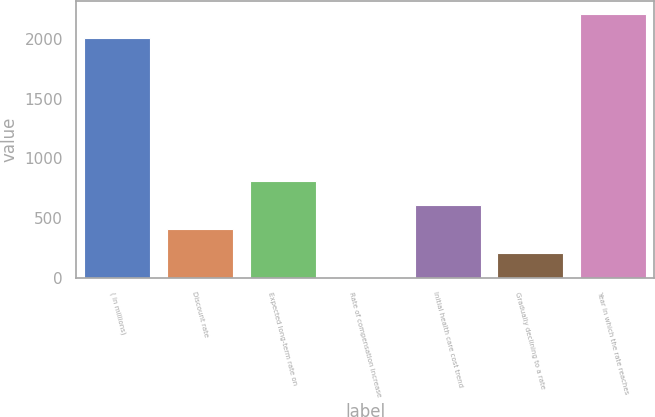<chart> <loc_0><loc_0><loc_500><loc_500><bar_chart><fcel>( in millions)<fcel>Discount rate<fcel>Expected long-term rate on<fcel>Rate of compensation increase<fcel>Initial health care cost trend<fcel>Gradually declining to a rate<fcel>Year in which the rate reaches<nl><fcel>2010<fcel>405.61<fcel>807.71<fcel>3.51<fcel>606.66<fcel>204.56<fcel>2211.05<nl></chart> 